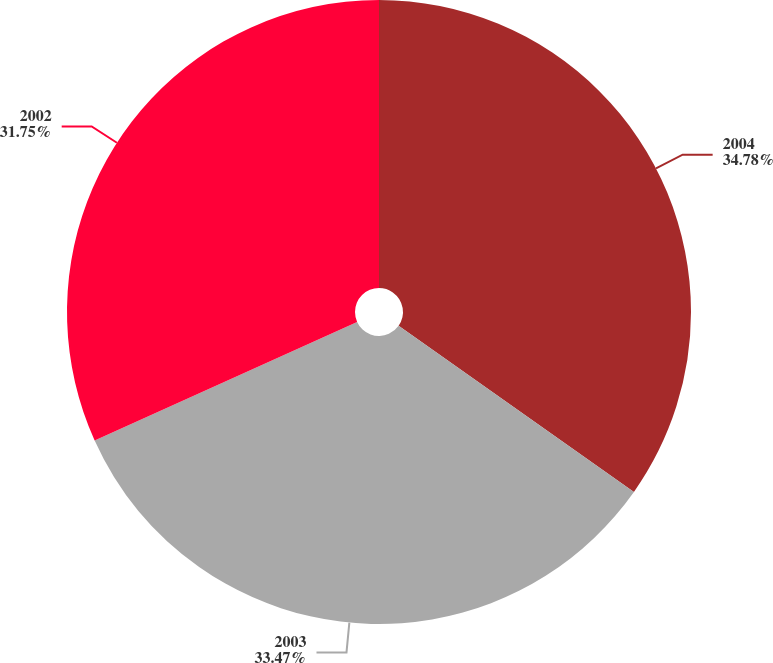Convert chart to OTSL. <chart><loc_0><loc_0><loc_500><loc_500><pie_chart><fcel>2004<fcel>2003<fcel>2002<nl><fcel>34.78%<fcel>33.47%<fcel>31.75%<nl></chart> 